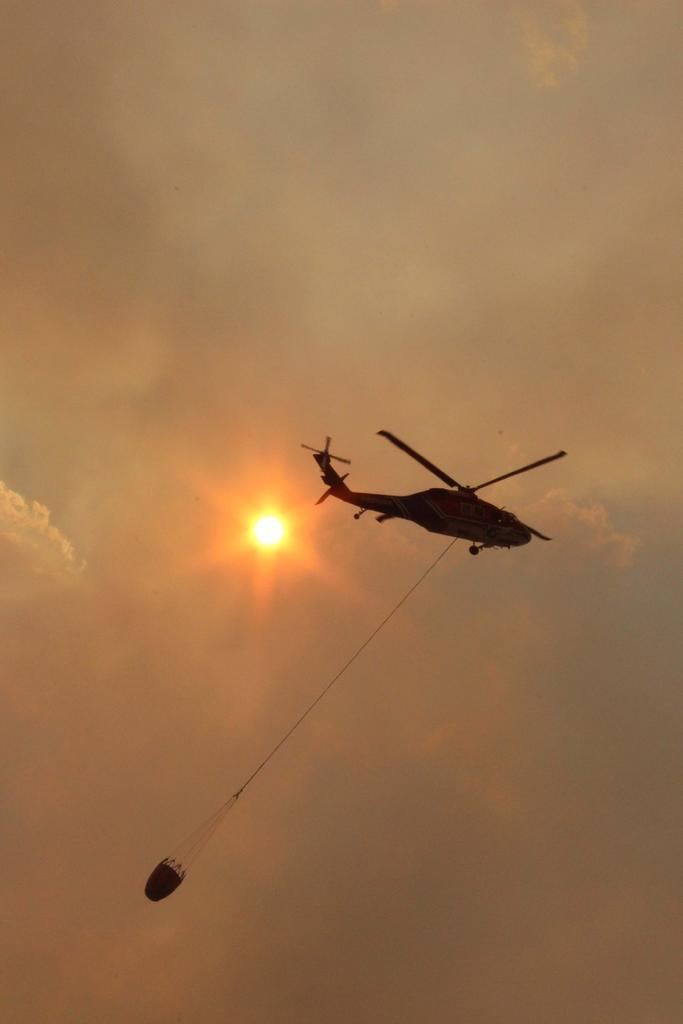What is the main subject of the image? The main subject of the image is a helicopter. What is the helicopter doing in the image? The helicopter is flying in the air. Is there anything attached to the helicopter? Yes, there is something tied to the helicopter. What can be seen in the sky in the background of the image? There is a sun and clouds in the sky in the background. Can you tell me how many men are observing the helicopter from the jar in the image? There is no jar or men present in the image; it features a helicopter flying in the air with something tied to it. 